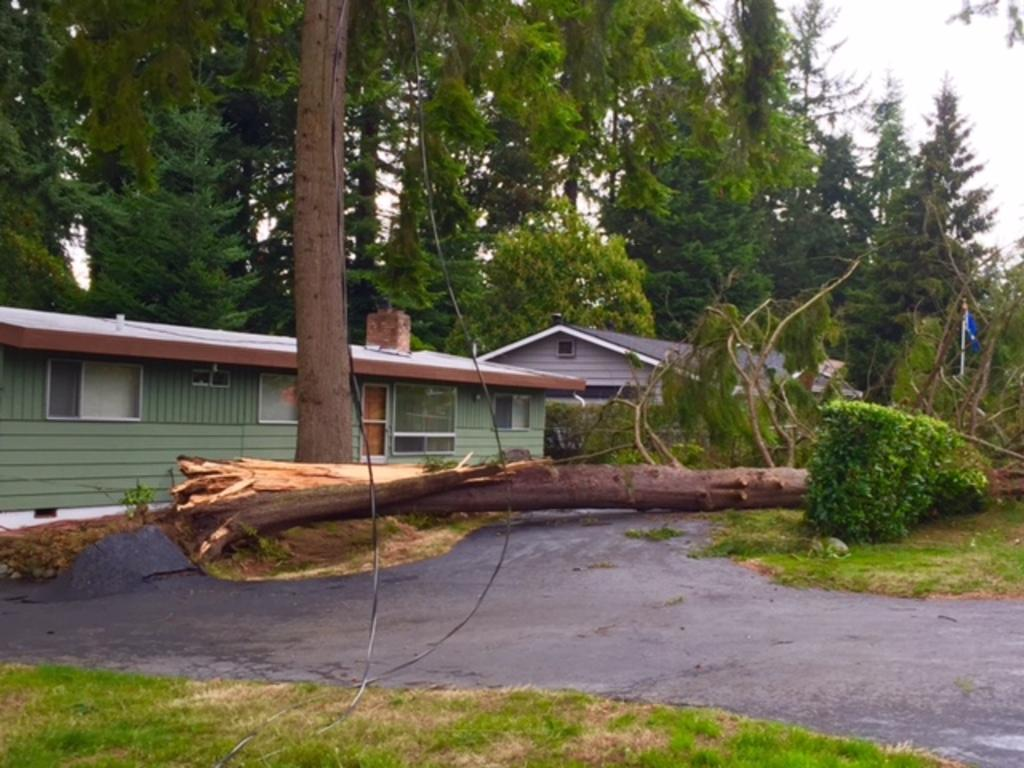What type of vegetation is at the bottom of the image? There is grass at the bottom of the image. What can be seen in the middle of the image? There is a fallen tree in the middle of the image. What structures are visible in the background of the image? There are houses and trees in the background of the image. What is visible at the top of the image? The sky is visible at the top of the image. What time of day is the horse event taking place in the image? There is no horse or event present in the image. What type of morning activity is happening in the image? There is no morning activity or reference to time of day in the image. 